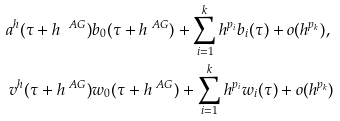<formula> <loc_0><loc_0><loc_500><loc_500>a ^ { h } ( \tau + h ^ { \ A G } ) & b _ { 0 } ( \tau + h ^ { \ A G } ) + \sum _ { i = 1 } ^ { k } h ^ { p _ { i } } b _ { i } ( \tau ) + o ( h ^ { p _ { k } } ) , \\ v ^ { h } ( \tau + h ^ { \ A G } ) & w _ { 0 } ( \tau + h ^ { \ A G } ) + \sum _ { i = 1 } ^ { k } h ^ { p _ { i } } w _ { i } ( \tau ) + o ( h ^ { p _ { k } } )</formula> 